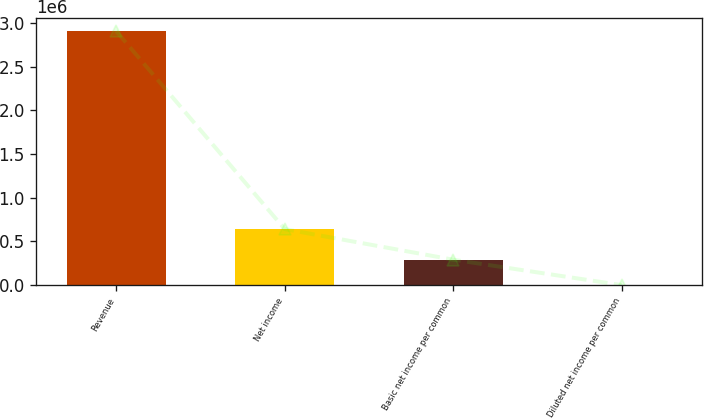Convert chart. <chart><loc_0><loc_0><loc_500><loc_500><bar_chart><fcel>Revenue<fcel>Net income<fcel>Basic net income per common<fcel>Diluted net income per common<nl><fcel>2.9075e+06<fcel>641217<fcel>290752<fcel>2.04<nl></chart> 